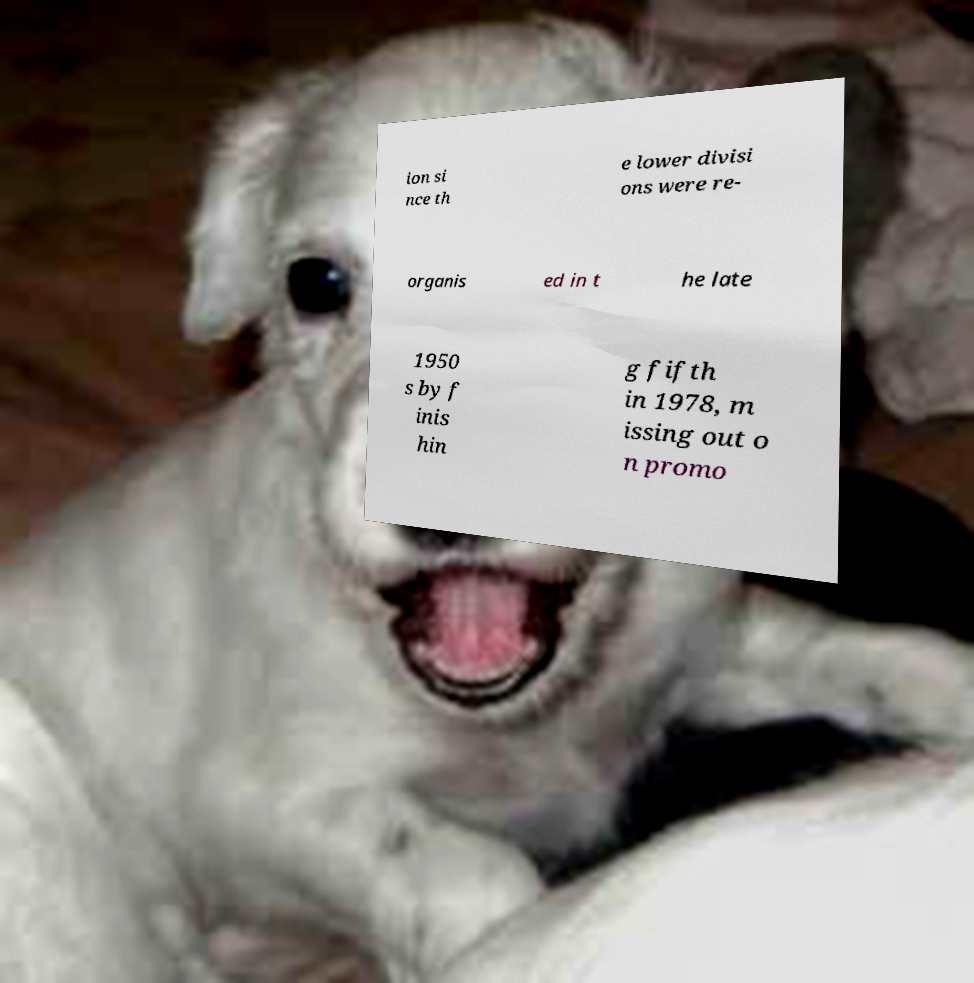Could you assist in decoding the text presented in this image and type it out clearly? ion si nce th e lower divisi ons were re- organis ed in t he late 1950 s by f inis hin g fifth in 1978, m issing out o n promo 